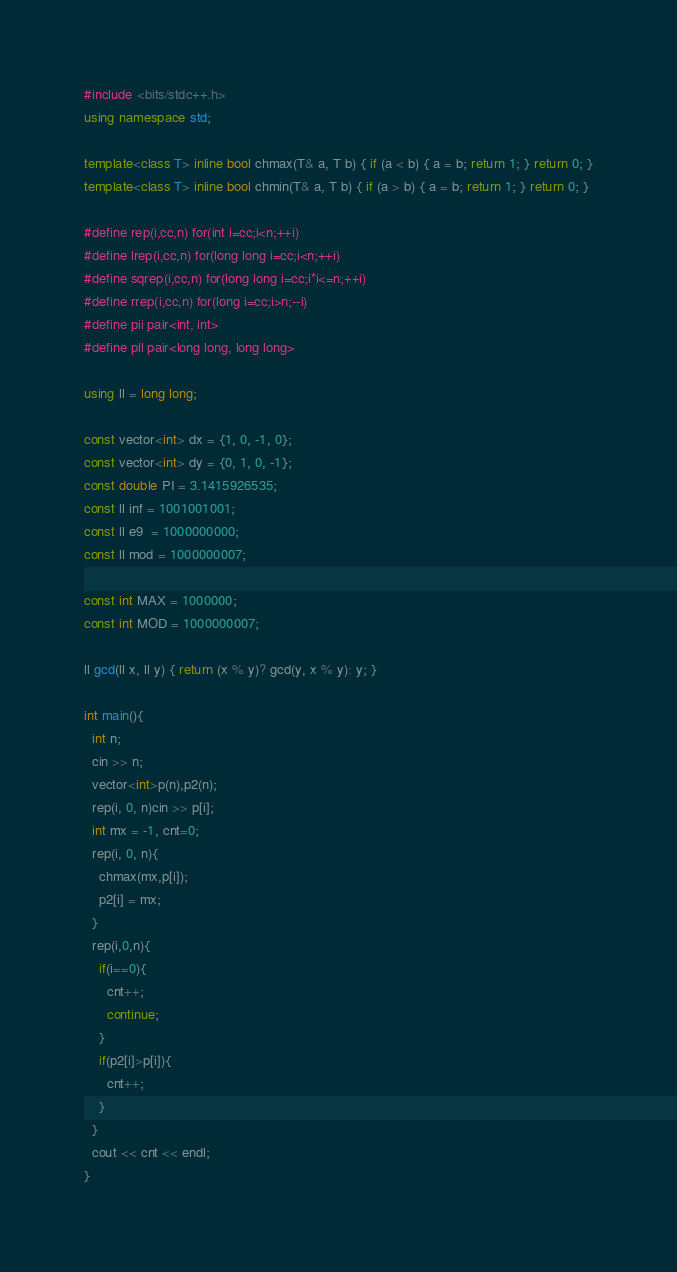Convert code to text. <code><loc_0><loc_0><loc_500><loc_500><_C++_>#include <bits/stdc++.h>
using namespace std;

template<class T> inline bool chmax(T& a, T b) { if (a < b) { a = b; return 1; } return 0; }
template<class T> inline bool chmin(T& a, T b) { if (a > b) { a = b; return 1; } return 0; }

#define rep(i,cc,n) for(int i=cc;i<n;++i)
#define lrep(i,cc,n) for(long long i=cc;i<n;++i)
#define sqrep(i,cc,n) for(long long i=cc;i*i<=n;++i)
#define rrep(i,cc,n) for(long i=cc;i>n;--i)
#define pii pair<int, int>
#define pll pair<long long, long long>
 
using ll = long long;

const vector<int> dx = {1, 0, -1, 0};
const vector<int> dy = {0, 1, 0, -1};
const double PI = 3.1415926535;
const ll inf = 1001001001;
const ll e9  = 1000000000;
const ll mod = 1000000007;

const int MAX = 1000000;
const int MOD = 1000000007;

ll gcd(ll x, ll y) { return (x % y)? gcd(y, x % y): y; }

int main(){
  int n;
  cin >> n;
  vector<int>p(n),p2(n);
  rep(i, 0, n)cin >> p[i];
  int mx = -1, cnt=0;
  rep(i, 0, n){
    chmax(mx,p[i]);
    p2[i] = mx; 
  }
  rep(i,0,n){
    if(i==0){
      cnt++;
      continue;
    }
    if(p2[i]>p[i]){
      cnt++;
    }
  }
  cout << cnt << endl;
}</code> 